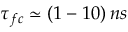Convert formula to latex. <formula><loc_0><loc_0><loc_500><loc_500>\tau _ { f c } \simeq ( 1 - 1 0 ) \, n s</formula> 